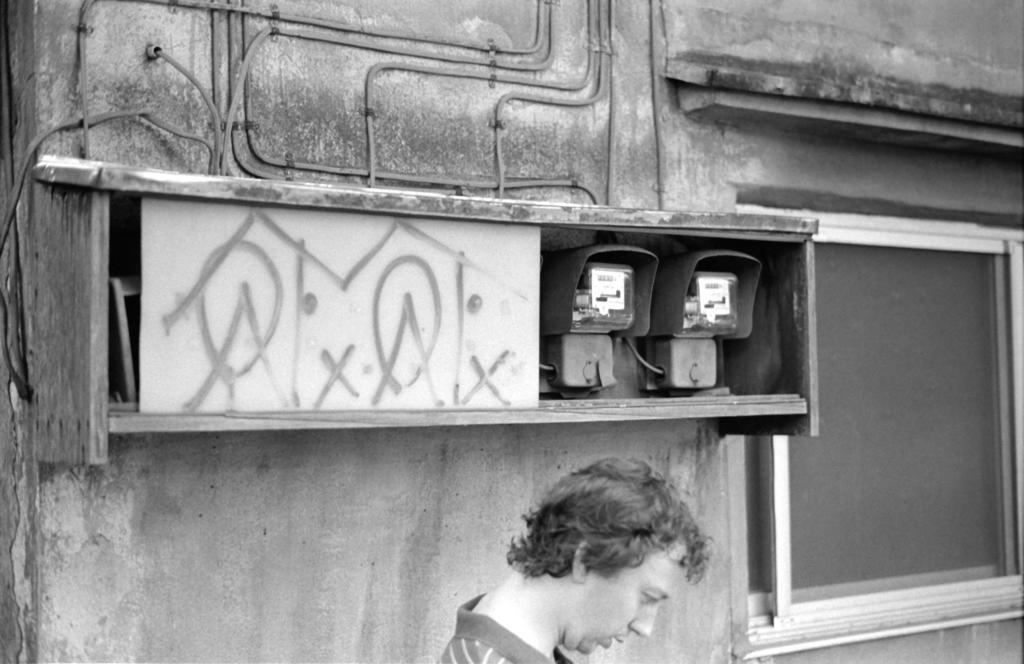Who or what is present in the image? There is a person in the image. What objects can be seen in the image related to measurements? There are meter boards in the image. What architectural feature is visible in the image? There are windows in the image. What object is present that can be used for play or sports? There is a ball in the image. What color scheme is used in the image? The image is in black and white. Where is the cave located in the image? There is no cave present in the image. What type of flower can be seen growing near the person in the image? There are no flowers present in the image. 